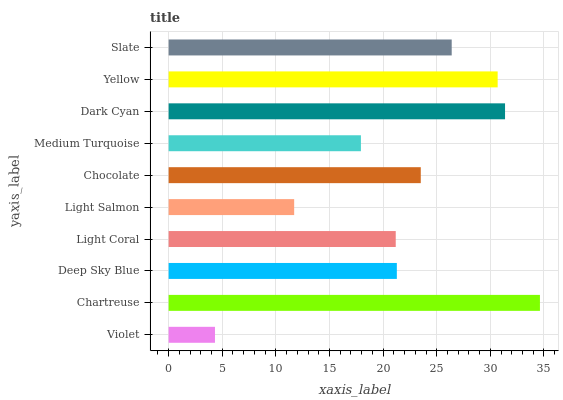Is Violet the minimum?
Answer yes or no. Yes. Is Chartreuse the maximum?
Answer yes or no. Yes. Is Deep Sky Blue the minimum?
Answer yes or no. No. Is Deep Sky Blue the maximum?
Answer yes or no. No. Is Chartreuse greater than Deep Sky Blue?
Answer yes or no. Yes. Is Deep Sky Blue less than Chartreuse?
Answer yes or no. Yes. Is Deep Sky Blue greater than Chartreuse?
Answer yes or no. No. Is Chartreuse less than Deep Sky Blue?
Answer yes or no. No. Is Chocolate the high median?
Answer yes or no. Yes. Is Deep Sky Blue the low median?
Answer yes or no. Yes. Is Light Salmon the high median?
Answer yes or no. No. Is Dark Cyan the low median?
Answer yes or no. No. 